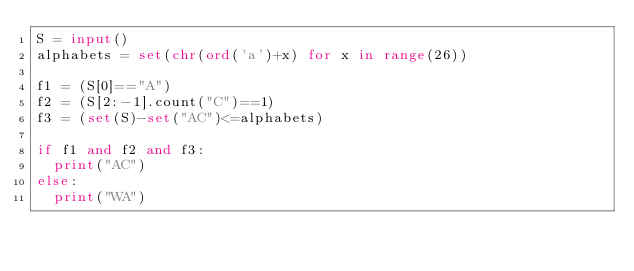Convert code to text. <code><loc_0><loc_0><loc_500><loc_500><_Python_>S = input()
alphabets = set(chr(ord('a')+x) for x in range(26))

f1 = (S[0]=="A")
f2 = (S[2:-1].count("C")==1)
f3 = (set(S)-set("AC")<=alphabets)

if f1 and f2 and f3:
  print("AC")
else:
  print("WA")</code> 